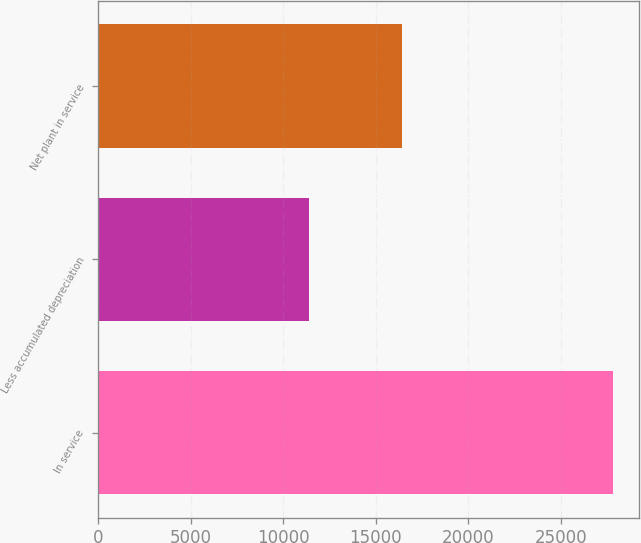Convert chart. <chart><loc_0><loc_0><loc_500><loc_500><bar_chart><fcel>In service<fcel>Less accumulated depreciation<fcel>Net plant in service<nl><fcel>27826<fcel>11397<fcel>16429<nl></chart> 